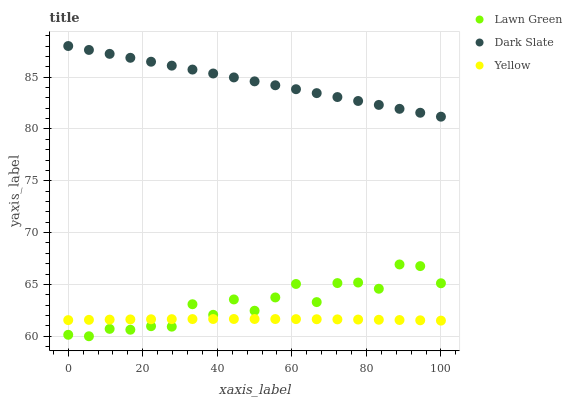Does Yellow have the minimum area under the curve?
Answer yes or no. Yes. Does Dark Slate have the maximum area under the curve?
Answer yes or no. Yes. Does Dark Slate have the minimum area under the curve?
Answer yes or no. No. Does Yellow have the maximum area under the curve?
Answer yes or no. No. Is Dark Slate the smoothest?
Answer yes or no. Yes. Is Lawn Green the roughest?
Answer yes or no. Yes. Is Yellow the smoothest?
Answer yes or no. No. Is Yellow the roughest?
Answer yes or no. No. Does Lawn Green have the lowest value?
Answer yes or no. Yes. Does Yellow have the lowest value?
Answer yes or no. No. Does Dark Slate have the highest value?
Answer yes or no. Yes. Does Yellow have the highest value?
Answer yes or no. No. Is Yellow less than Dark Slate?
Answer yes or no. Yes. Is Dark Slate greater than Lawn Green?
Answer yes or no. Yes. Does Yellow intersect Lawn Green?
Answer yes or no. Yes. Is Yellow less than Lawn Green?
Answer yes or no. No. Is Yellow greater than Lawn Green?
Answer yes or no. No. Does Yellow intersect Dark Slate?
Answer yes or no. No. 